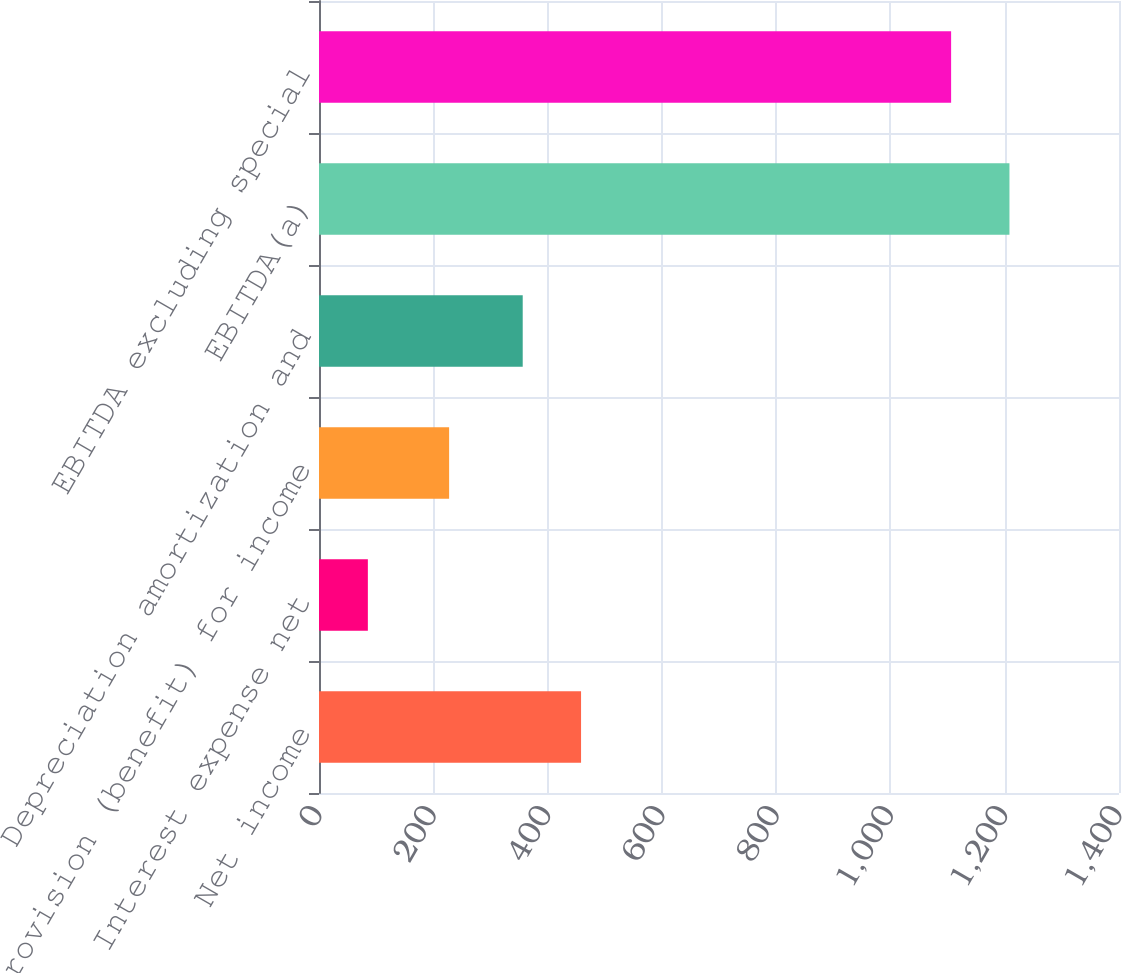Convert chart to OTSL. <chart><loc_0><loc_0><loc_500><loc_500><bar_chart><fcel>Net income<fcel>Interest expense net<fcel>Provision (benefit) for income<fcel>Depreciation amortization and<fcel>EBITDA(a)<fcel>EBITDA excluding special<nl><fcel>458.6<fcel>85.5<fcel>227.7<fcel>356.5<fcel>1208.3<fcel>1106.2<nl></chart> 